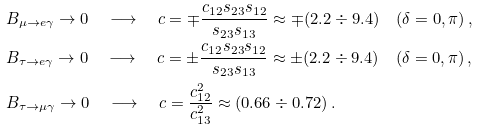Convert formula to latex. <formula><loc_0><loc_0><loc_500><loc_500>& B _ { \mu \rightarrow e \gamma } \to 0 \quad \longrightarrow \quad c = \mp \frac { c _ { 1 2 } s _ { 2 3 } s _ { 1 2 } } { s _ { 2 3 } s _ { 1 3 } } \approx \mp ( 2 . 2 \div 9 . 4 ) \quad ( \delta = 0 , \pi ) \, , \\ & B _ { \tau \rightarrow e \gamma } \rightarrow 0 \quad \longrightarrow \quad c = \pm \frac { c _ { 1 2 } s _ { 2 3 } s _ { 1 2 } } { s _ { 2 3 } s _ { 1 3 } } \approx \pm ( 2 . 2 \div 9 . 4 ) \quad ( \delta = 0 , \pi ) \, , \\ & B _ { \tau \rightarrow \mu \gamma } \rightarrow 0 \quad \longrightarrow \quad c = \frac { c _ { 1 2 } ^ { 2 } } { c _ { 1 3 } ^ { 2 } } \approx ( 0 . 6 6 \div 0 . 7 2 ) \, .</formula> 